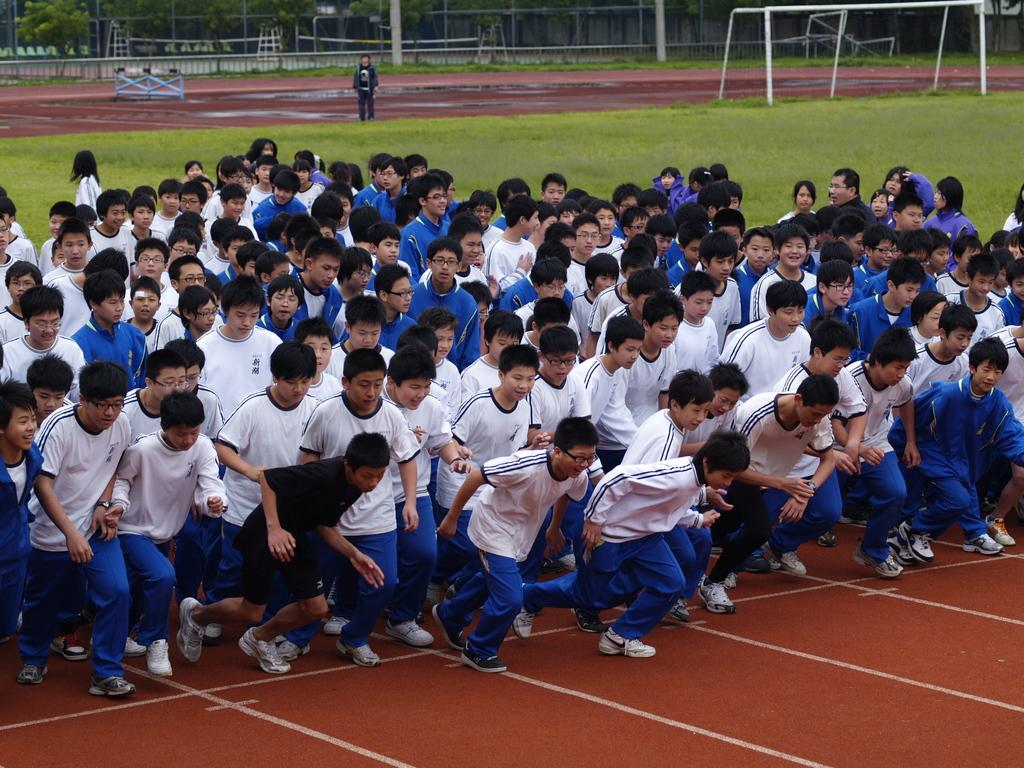What are the people in the image doing? The people in the image are running. What can be seen in the background of the image? In the background of the image, there are rods, a fence, and trees. Can you describe the rods in the background? The rods in the background are long, thin, and vertical. How does the glass affect the rainstorm in the image? There is no glass or rainstorm present in the image; it features people running with rods, a fence, and trees in the background. 